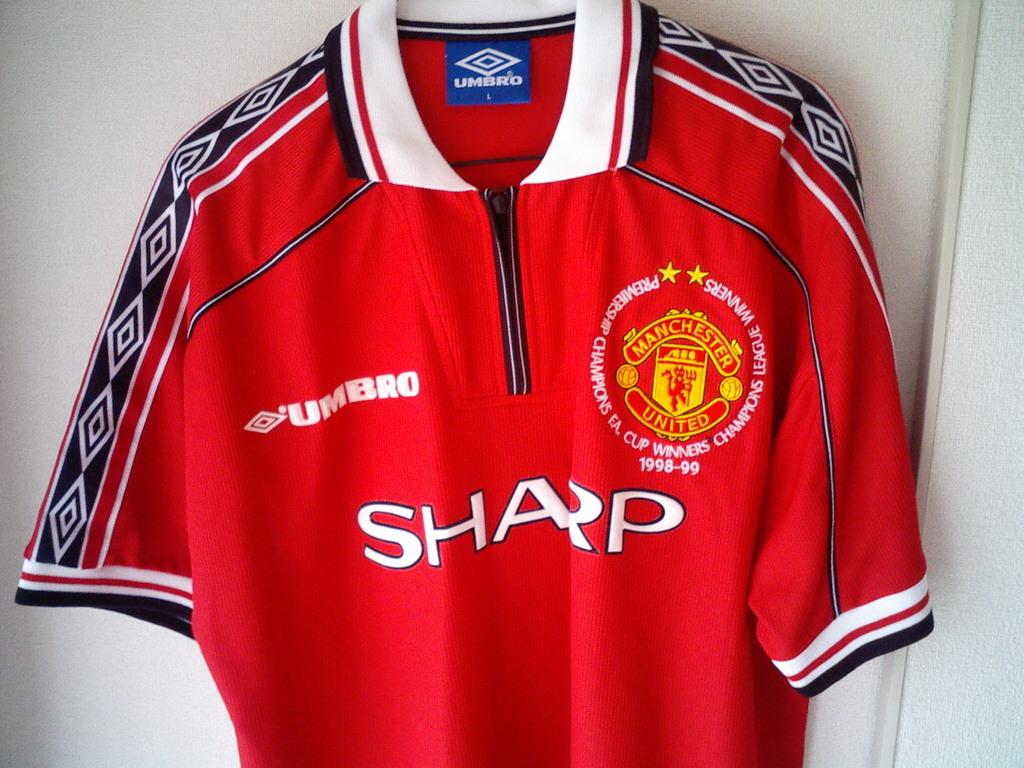What type of clothing is featured in the image? There is a red t-shirt with logos on it in the image. What can be seen in the background of the image? There is a wall in the background of the image. What actor is wearing the red t-shirt in the image? There is no actor present in the image; it is a t-shirt with logos on it. Can you describe the curve of the t-shirt in the image? The facts provided do not mention any specific curve of the t-shirt, so it cannot be described. 